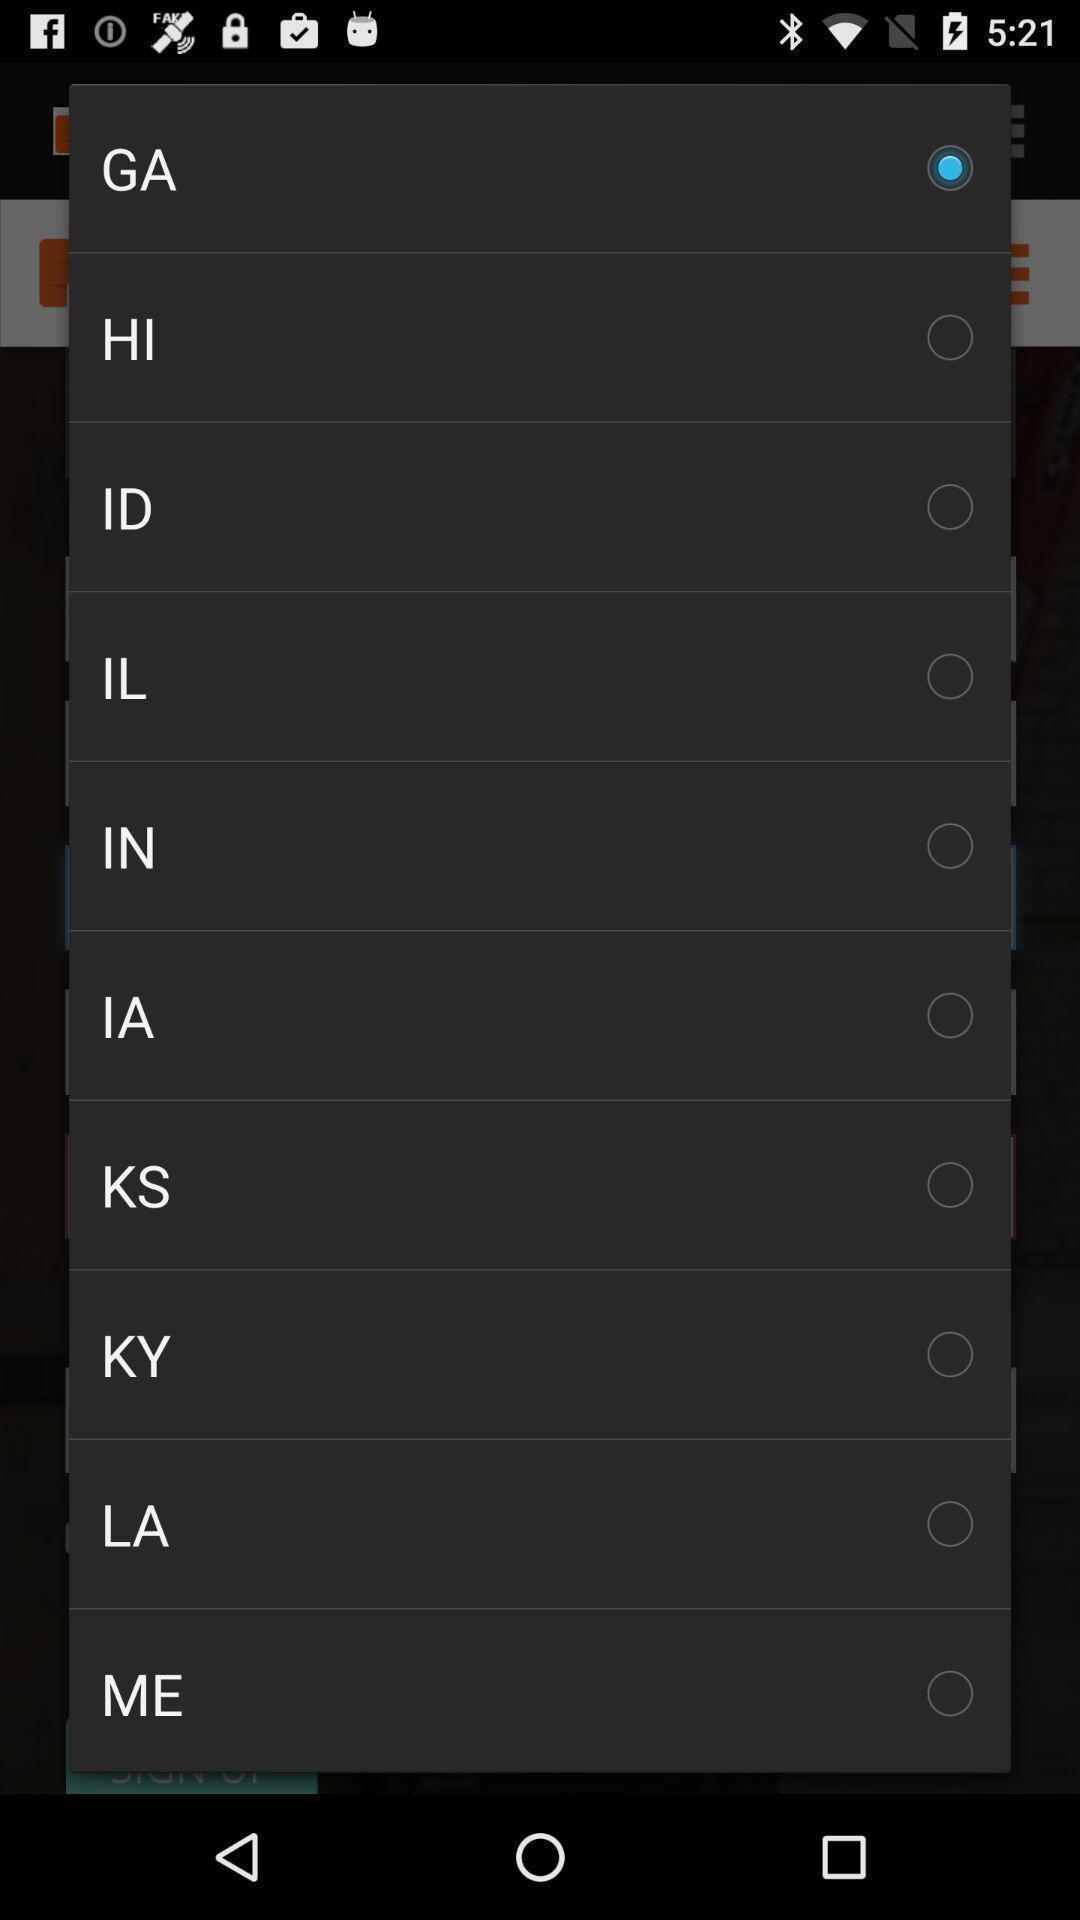Provide a textual representation of this image. Pop-up showing list of shortcuts of various locations. 